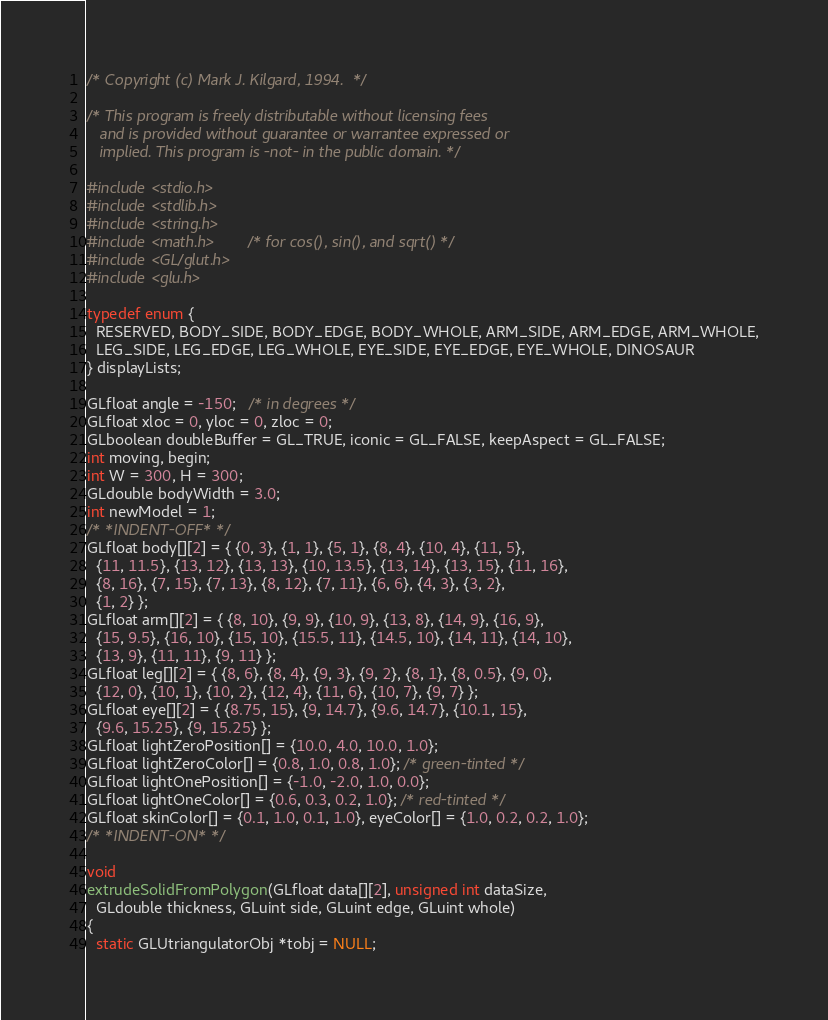Convert code to text. <code><loc_0><loc_0><loc_500><loc_500><_C++_>
/* Copyright (c) Mark J. Kilgard, 1994.  */

/* This program is freely distributable without licensing fees 
   and is provided without guarantee or warrantee expressed or 
   implied. This program is -not- in the public domain. */

#include <stdio.h>
#include <stdlib.h>
#include <string.h>
#include <math.h>       /* for cos(), sin(), and sqrt() */
#include <GL/glut.h>
#include <glu.h>

typedef enum {
  RESERVED, BODY_SIDE, BODY_EDGE, BODY_WHOLE, ARM_SIDE, ARM_EDGE, ARM_WHOLE,
  LEG_SIDE, LEG_EDGE, LEG_WHOLE, EYE_SIDE, EYE_EDGE, EYE_WHOLE, DINOSAUR
} displayLists;

GLfloat angle = -150;   /* in degrees */
GLfloat xloc = 0, yloc = 0, zloc = 0;
GLboolean doubleBuffer = GL_TRUE, iconic = GL_FALSE, keepAspect = GL_FALSE;
int moving, begin;
int W = 300, H = 300;
GLdouble bodyWidth = 3.0;
int newModel = 1;
/* *INDENT-OFF* */
GLfloat body[][2] = { {0, 3}, {1, 1}, {5, 1}, {8, 4}, {10, 4}, {11, 5},
  {11, 11.5}, {13, 12}, {13, 13}, {10, 13.5}, {13, 14}, {13, 15}, {11, 16},
  {8, 16}, {7, 15}, {7, 13}, {8, 12}, {7, 11}, {6, 6}, {4, 3}, {3, 2},
  {1, 2} };
GLfloat arm[][2] = { {8, 10}, {9, 9}, {10, 9}, {13, 8}, {14, 9}, {16, 9},
  {15, 9.5}, {16, 10}, {15, 10}, {15.5, 11}, {14.5, 10}, {14, 11}, {14, 10},
  {13, 9}, {11, 11}, {9, 11} };
GLfloat leg[][2] = { {8, 6}, {8, 4}, {9, 3}, {9, 2}, {8, 1}, {8, 0.5}, {9, 0},
  {12, 0}, {10, 1}, {10, 2}, {12, 4}, {11, 6}, {10, 7}, {9, 7} };
GLfloat eye[][2] = { {8.75, 15}, {9, 14.7}, {9.6, 14.7}, {10.1, 15},
  {9.6, 15.25}, {9, 15.25} };
GLfloat lightZeroPosition[] = {10.0, 4.0, 10.0, 1.0};
GLfloat lightZeroColor[] = {0.8, 1.0, 0.8, 1.0}; /* green-tinted */
GLfloat lightOnePosition[] = {-1.0, -2.0, 1.0, 0.0};
GLfloat lightOneColor[] = {0.6, 0.3, 0.2, 1.0}; /* red-tinted */
GLfloat skinColor[] = {0.1, 1.0, 0.1, 1.0}, eyeColor[] = {1.0, 0.2, 0.2, 1.0};
/* *INDENT-ON* */

void
extrudeSolidFromPolygon(GLfloat data[][2], unsigned int dataSize,
  GLdouble thickness, GLuint side, GLuint edge, GLuint whole)
{
  static GLUtriangulatorObj *tobj = NULL;</code> 